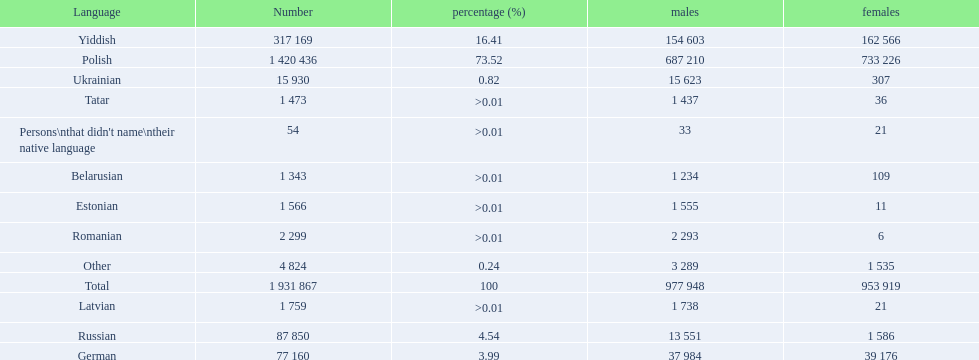What named native languages spoken in the warsaw governorate have more males then females? Russian, Ukrainian, Romanian, Latvian, Estonian, Tatar, Belarusian. Which of those have less then 500 males listed? Romanian, Latvian, Estonian, Tatar, Belarusian. Of the remaining languages which of them have less then 20 females? Romanian, Estonian. Which of these has the highest total number listed? Romanian. 